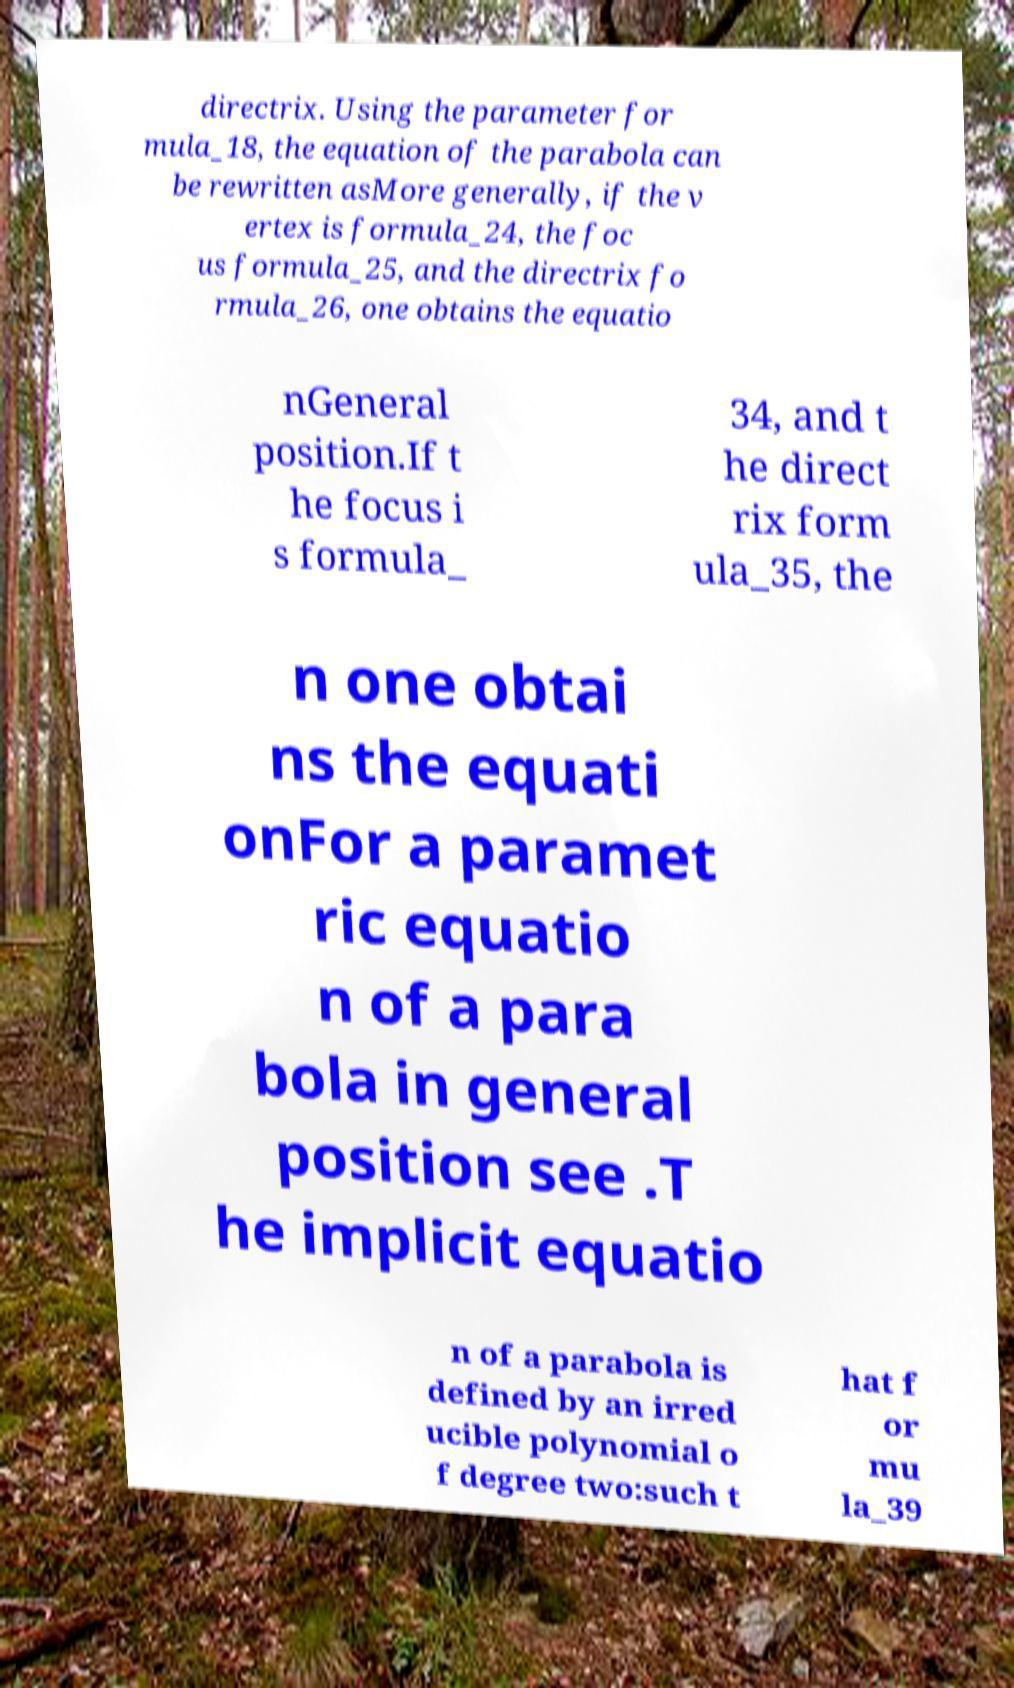Can you read and provide the text displayed in the image?This photo seems to have some interesting text. Can you extract and type it out for me? directrix. Using the parameter for mula_18, the equation of the parabola can be rewritten asMore generally, if the v ertex is formula_24, the foc us formula_25, and the directrix fo rmula_26, one obtains the equatio nGeneral position.If t he focus i s formula_ 34, and t he direct rix form ula_35, the n one obtai ns the equati onFor a paramet ric equatio n of a para bola in general position see .T he implicit equatio n of a parabola is defined by an irred ucible polynomial o f degree two:such t hat f or mu la_39 